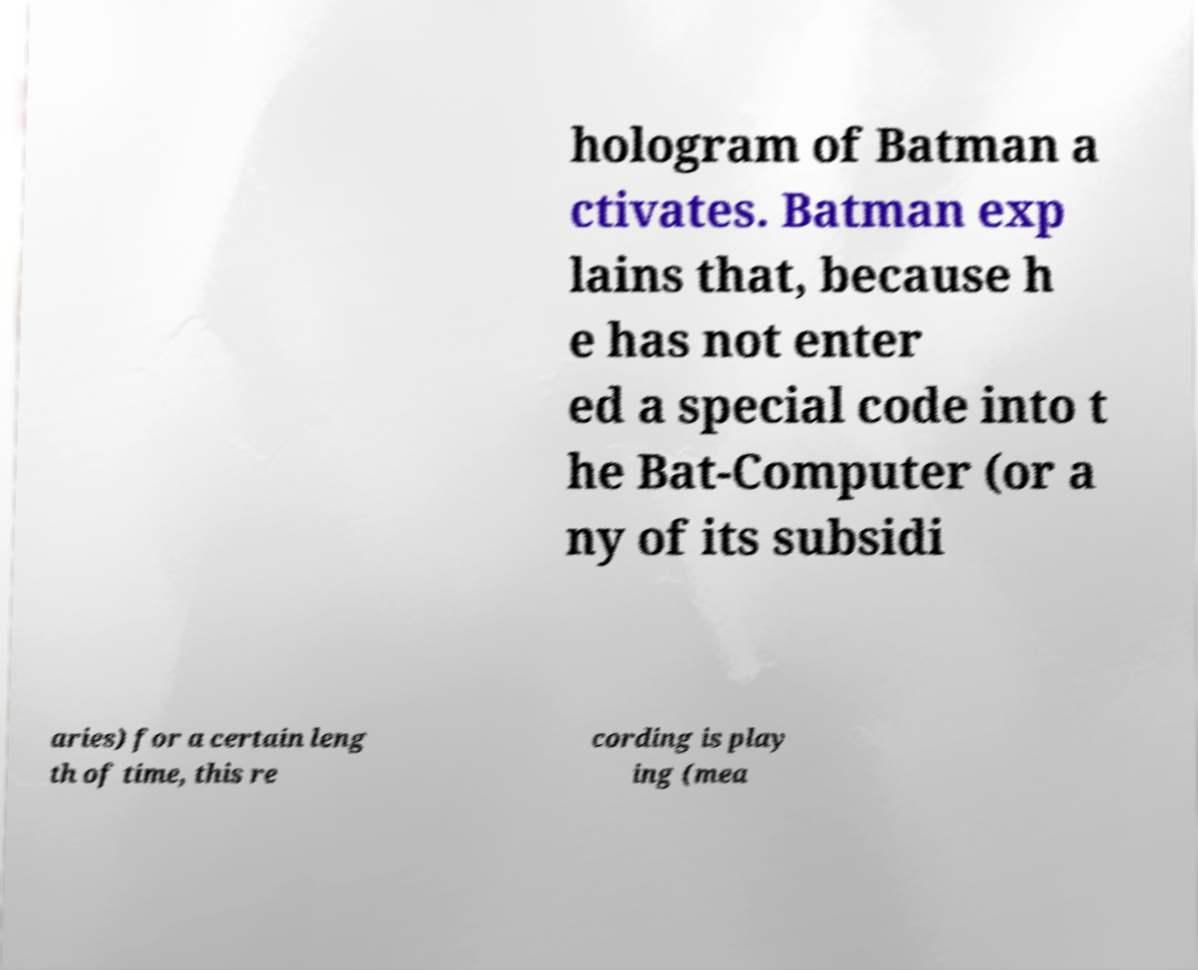I need the written content from this picture converted into text. Can you do that? hologram of Batman a ctivates. Batman exp lains that, because h e has not enter ed a special code into t he Bat-Computer (or a ny of its subsidi aries) for a certain leng th of time, this re cording is play ing (mea 